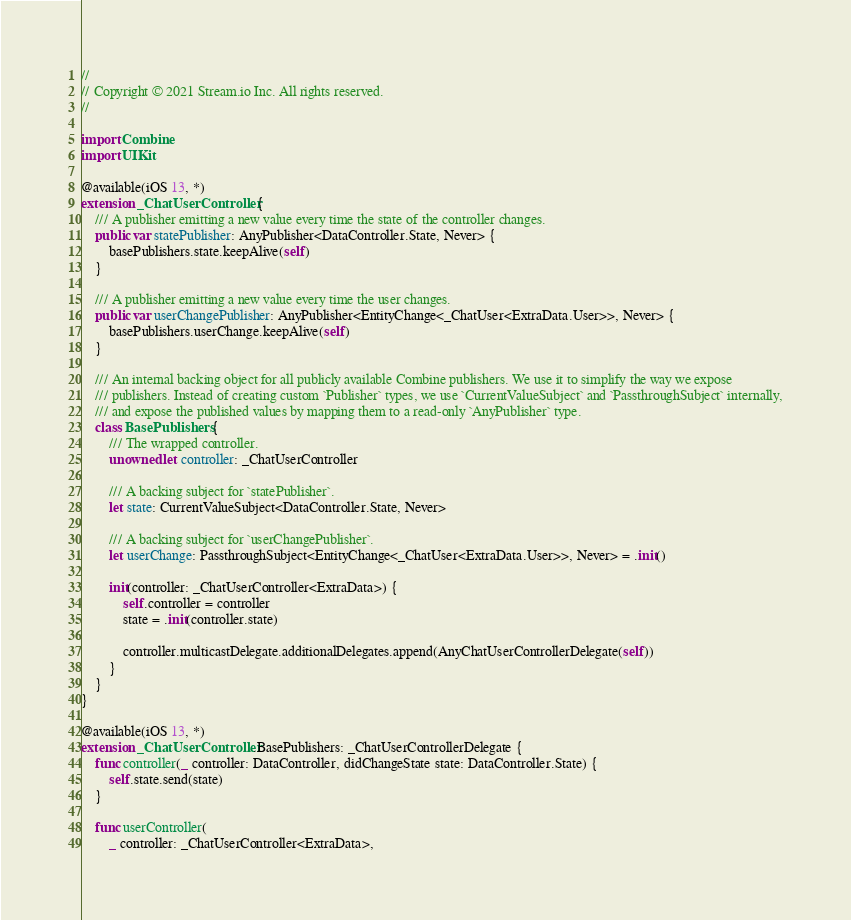Convert code to text. <code><loc_0><loc_0><loc_500><loc_500><_Swift_>//
// Copyright © 2021 Stream.io Inc. All rights reserved.
//

import Combine
import UIKit

@available(iOS 13, *)
extension _ChatUserController {
    /// A publisher emitting a new value every time the state of the controller changes.
    public var statePublisher: AnyPublisher<DataController.State, Never> {
        basePublishers.state.keepAlive(self)
    }
    
    /// A publisher emitting a new value every time the user changes.
    public var userChangePublisher: AnyPublisher<EntityChange<_ChatUser<ExtraData.User>>, Never> {
        basePublishers.userChange.keepAlive(self)
    }
    
    /// An internal backing object for all publicly available Combine publishers. We use it to simplify the way we expose
    /// publishers. Instead of creating custom `Publisher` types, we use `CurrentValueSubject` and `PassthroughSubject` internally,
    /// and expose the published values by mapping them to a read-only `AnyPublisher` type.
    class BasePublishers {
        /// The wrapped controller.
        unowned let controller: _ChatUserController
        
        /// A backing subject for `statePublisher`.
        let state: CurrentValueSubject<DataController.State, Never>
        
        /// A backing subject for `userChangePublisher`.
        let userChange: PassthroughSubject<EntityChange<_ChatUser<ExtraData.User>>, Never> = .init()
        
        init(controller: _ChatUserController<ExtraData>) {
            self.controller = controller
            state = .init(controller.state)
            
            controller.multicastDelegate.additionalDelegates.append(AnyChatUserControllerDelegate(self))
        }
    }
}

@available(iOS 13, *)
extension _ChatUserController.BasePublishers: _ChatUserControllerDelegate {
    func controller(_ controller: DataController, didChangeState state: DataController.State) {
        self.state.send(state)
    }

    func userController(
        _ controller: _ChatUserController<ExtraData>,</code> 